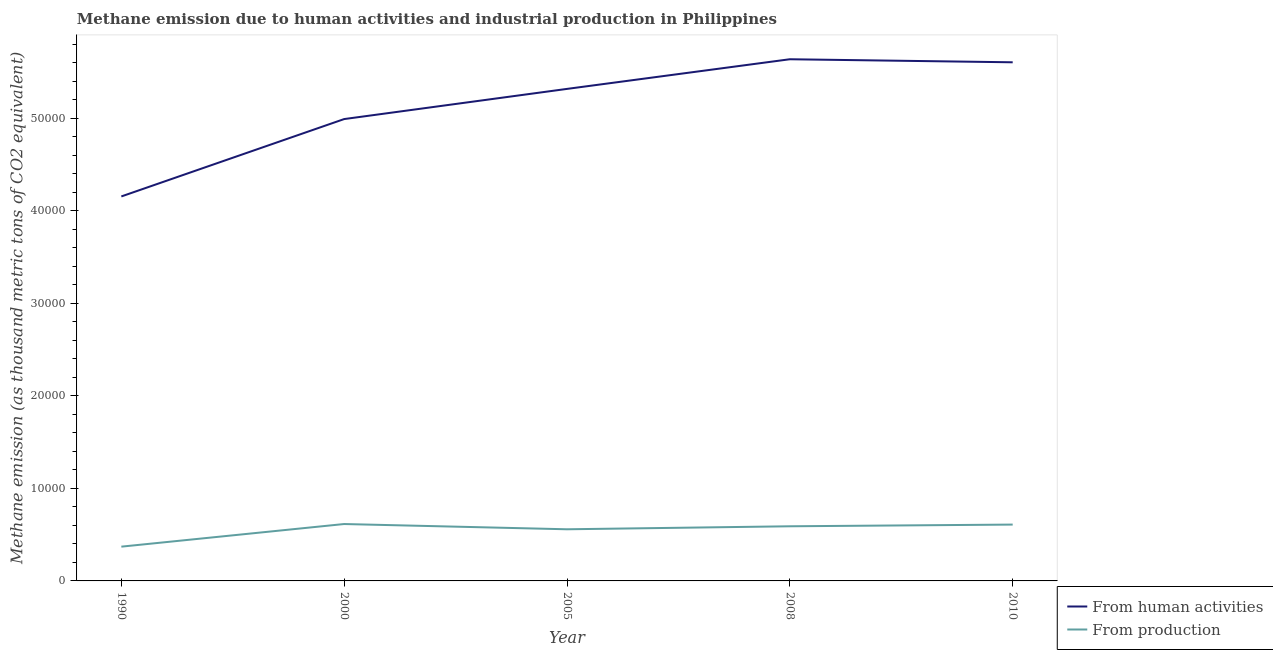Does the line corresponding to amount of emissions generated from industries intersect with the line corresponding to amount of emissions from human activities?
Make the answer very short. No. What is the amount of emissions from human activities in 2005?
Provide a short and direct response. 5.32e+04. Across all years, what is the maximum amount of emissions generated from industries?
Your answer should be very brief. 6149.1. Across all years, what is the minimum amount of emissions from human activities?
Give a very brief answer. 4.16e+04. In which year was the amount of emissions generated from industries minimum?
Keep it short and to the point. 1990. What is the total amount of emissions from human activities in the graph?
Your answer should be very brief. 2.57e+05. What is the difference between the amount of emissions generated from industries in 2005 and that in 2010?
Your answer should be compact. -507.9. What is the difference between the amount of emissions generated from industries in 2010 and the amount of emissions from human activities in 2005?
Ensure brevity in your answer.  -4.71e+04. What is the average amount of emissions from human activities per year?
Offer a terse response. 5.14e+04. In the year 2010, what is the difference between the amount of emissions generated from industries and amount of emissions from human activities?
Your answer should be very brief. -5.00e+04. In how many years, is the amount of emissions from human activities greater than 42000 thousand metric tons?
Make the answer very short. 4. What is the ratio of the amount of emissions generated from industries in 2000 to that in 2005?
Make the answer very short. 1.1. What is the difference between the highest and the second highest amount of emissions from human activities?
Offer a very short reply. 330.4. What is the difference between the highest and the lowest amount of emissions generated from industries?
Your answer should be very brief. 2444.9. In how many years, is the amount of emissions generated from industries greater than the average amount of emissions generated from industries taken over all years?
Your response must be concise. 4. Is the sum of the amount of emissions from human activities in 2005 and 2008 greater than the maximum amount of emissions generated from industries across all years?
Provide a short and direct response. Yes. Is the amount of emissions from human activities strictly greater than the amount of emissions generated from industries over the years?
Offer a very short reply. Yes. What is the difference between two consecutive major ticks on the Y-axis?
Ensure brevity in your answer.  10000. Where does the legend appear in the graph?
Provide a short and direct response. Bottom right. What is the title of the graph?
Provide a short and direct response. Methane emission due to human activities and industrial production in Philippines. Does "Methane" appear as one of the legend labels in the graph?
Make the answer very short. No. What is the label or title of the Y-axis?
Your answer should be compact. Methane emission (as thousand metric tons of CO2 equivalent). What is the Methane emission (as thousand metric tons of CO2 equivalent) in From human activities in 1990?
Offer a very short reply. 4.16e+04. What is the Methane emission (as thousand metric tons of CO2 equivalent) of From production in 1990?
Your response must be concise. 3704.2. What is the Methane emission (as thousand metric tons of CO2 equivalent) of From human activities in 2000?
Your answer should be compact. 4.99e+04. What is the Methane emission (as thousand metric tons of CO2 equivalent) of From production in 2000?
Make the answer very short. 6149.1. What is the Methane emission (as thousand metric tons of CO2 equivalent) in From human activities in 2005?
Keep it short and to the point. 5.32e+04. What is the Methane emission (as thousand metric tons of CO2 equivalent) of From production in 2005?
Ensure brevity in your answer.  5580.9. What is the Methane emission (as thousand metric tons of CO2 equivalent) of From human activities in 2008?
Offer a very short reply. 5.64e+04. What is the Methane emission (as thousand metric tons of CO2 equivalent) in From production in 2008?
Ensure brevity in your answer.  5905.9. What is the Methane emission (as thousand metric tons of CO2 equivalent) of From human activities in 2010?
Offer a very short reply. 5.60e+04. What is the Methane emission (as thousand metric tons of CO2 equivalent) of From production in 2010?
Offer a terse response. 6088.8. Across all years, what is the maximum Methane emission (as thousand metric tons of CO2 equivalent) in From human activities?
Keep it short and to the point. 5.64e+04. Across all years, what is the maximum Methane emission (as thousand metric tons of CO2 equivalent) of From production?
Keep it short and to the point. 6149.1. Across all years, what is the minimum Methane emission (as thousand metric tons of CO2 equivalent) in From human activities?
Make the answer very short. 4.16e+04. Across all years, what is the minimum Methane emission (as thousand metric tons of CO2 equivalent) in From production?
Provide a short and direct response. 3704.2. What is the total Methane emission (as thousand metric tons of CO2 equivalent) of From human activities in the graph?
Provide a succinct answer. 2.57e+05. What is the total Methane emission (as thousand metric tons of CO2 equivalent) of From production in the graph?
Provide a short and direct response. 2.74e+04. What is the difference between the Methane emission (as thousand metric tons of CO2 equivalent) of From human activities in 1990 and that in 2000?
Provide a short and direct response. -8363.6. What is the difference between the Methane emission (as thousand metric tons of CO2 equivalent) in From production in 1990 and that in 2000?
Your answer should be compact. -2444.9. What is the difference between the Methane emission (as thousand metric tons of CO2 equivalent) of From human activities in 1990 and that in 2005?
Your answer should be very brief. -1.16e+04. What is the difference between the Methane emission (as thousand metric tons of CO2 equivalent) in From production in 1990 and that in 2005?
Offer a terse response. -1876.7. What is the difference between the Methane emission (as thousand metric tons of CO2 equivalent) in From human activities in 1990 and that in 2008?
Ensure brevity in your answer.  -1.48e+04. What is the difference between the Methane emission (as thousand metric tons of CO2 equivalent) in From production in 1990 and that in 2008?
Your response must be concise. -2201.7. What is the difference between the Methane emission (as thousand metric tons of CO2 equivalent) of From human activities in 1990 and that in 2010?
Your answer should be compact. -1.45e+04. What is the difference between the Methane emission (as thousand metric tons of CO2 equivalent) in From production in 1990 and that in 2010?
Offer a very short reply. -2384.6. What is the difference between the Methane emission (as thousand metric tons of CO2 equivalent) in From human activities in 2000 and that in 2005?
Make the answer very short. -3260.6. What is the difference between the Methane emission (as thousand metric tons of CO2 equivalent) in From production in 2000 and that in 2005?
Your answer should be compact. 568.2. What is the difference between the Methane emission (as thousand metric tons of CO2 equivalent) in From human activities in 2000 and that in 2008?
Your response must be concise. -6464.7. What is the difference between the Methane emission (as thousand metric tons of CO2 equivalent) in From production in 2000 and that in 2008?
Your answer should be very brief. 243.2. What is the difference between the Methane emission (as thousand metric tons of CO2 equivalent) of From human activities in 2000 and that in 2010?
Make the answer very short. -6134.3. What is the difference between the Methane emission (as thousand metric tons of CO2 equivalent) of From production in 2000 and that in 2010?
Provide a short and direct response. 60.3. What is the difference between the Methane emission (as thousand metric tons of CO2 equivalent) of From human activities in 2005 and that in 2008?
Provide a short and direct response. -3204.1. What is the difference between the Methane emission (as thousand metric tons of CO2 equivalent) in From production in 2005 and that in 2008?
Offer a very short reply. -325. What is the difference between the Methane emission (as thousand metric tons of CO2 equivalent) in From human activities in 2005 and that in 2010?
Ensure brevity in your answer.  -2873.7. What is the difference between the Methane emission (as thousand metric tons of CO2 equivalent) of From production in 2005 and that in 2010?
Provide a short and direct response. -507.9. What is the difference between the Methane emission (as thousand metric tons of CO2 equivalent) of From human activities in 2008 and that in 2010?
Ensure brevity in your answer.  330.4. What is the difference between the Methane emission (as thousand metric tons of CO2 equivalent) in From production in 2008 and that in 2010?
Offer a terse response. -182.9. What is the difference between the Methane emission (as thousand metric tons of CO2 equivalent) of From human activities in 1990 and the Methane emission (as thousand metric tons of CO2 equivalent) of From production in 2000?
Offer a terse response. 3.54e+04. What is the difference between the Methane emission (as thousand metric tons of CO2 equivalent) of From human activities in 1990 and the Methane emission (as thousand metric tons of CO2 equivalent) of From production in 2005?
Offer a very short reply. 3.60e+04. What is the difference between the Methane emission (as thousand metric tons of CO2 equivalent) in From human activities in 1990 and the Methane emission (as thousand metric tons of CO2 equivalent) in From production in 2008?
Your response must be concise. 3.56e+04. What is the difference between the Methane emission (as thousand metric tons of CO2 equivalent) of From human activities in 1990 and the Methane emission (as thousand metric tons of CO2 equivalent) of From production in 2010?
Make the answer very short. 3.55e+04. What is the difference between the Methane emission (as thousand metric tons of CO2 equivalent) in From human activities in 2000 and the Methane emission (as thousand metric tons of CO2 equivalent) in From production in 2005?
Provide a short and direct response. 4.43e+04. What is the difference between the Methane emission (as thousand metric tons of CO2 equivalent) of From human activities in 2000 and the Methane emission (as thousand metric tons of CO2 equivalent) of From production in 2008?
Give a very brief answer. 4.40e+04. What is the difference between the Methane emission (as thousand metric tons of CO2 equivalent) of From human activities in 2000 and the Methane emission (as thousand metric tons of CO2 equivalent) of From production in 2010?
Your answer should be very brief. 4.38e+04. What is the difference between the Methane emission (as thousand metric tons of CO2 equivalent) in From human activities in 2005 and the Methane emission (as thousand metric tons of CO2 equivalent) in From production in 2008?
Offer a terse response. 4.73e+04. What is the difference between the Methane emission (as thousand metric tons of CO2 equivalent) of From human activities in 2005 and the Methane emission (as thousand metric tons of CO2 equivalent) of From production in 2010?
Keep it short and to the point. 4.71e+04. What is the difference between the Methane emission (as thousand metric tons of CO2 equivalent) in From human activities in 2008 and the Methane emission (as thousand metric tons of CO2 equivalent) in From production in 2010?
Offer a very short reply. 5.03e+04. What is the average Methane emission (as thousand metric tons of CO2 equivalent) of From human activities per year?
Keep it short and to the point. 5.14e+04. What is the average Methane emission (as thousand metric tons of CO2 equivalent) in From production per year?
Your answer should be very brief. 5485.78. In the year 1990, what is the difference between the Methane emission (as thousand metric tons of CO2 equivalent) of From human activities and Methane emission (as thousand metric tons of CO2 equivalent) of From production?
Your answer should be very brief. 3.78e+04. In the year 2000, what is the difference between the Methane emission (as thousand metric tons of CO2 equivalent) of From human activities and Methane emission (as thousand metric tons of CO2 equivalent) of From production?
Keep it short and to the point. 4.38e+04. In the year 2005, what is the difference between the Methane emission (as thousand metric tons of CO2 equivalent) in From human activities and Methane emission (as thousand metric tons of CO2 equivalent) in From production?
Your answer should be very brief. 4.76e+04. In the year 2008, what is the difference between the Methane emission (as thousand metric tons of CO2 equivalent) of From human activities and Methane emission (as thousand metric tons of CO2 equivalent) of From production?
Ensure brevity in your answer.  5.05e+04. In the year 2010, what is the difference between the Methane emission (as thousand metric tons of CO2 equivalent) of From human activities and Methane emission (as thousand metric tons of CO2 equivalent) of From production?
Your answer should be compact. 5.00e+04. What is the ratio of the Methane emission (as thousand metric tons of CO2 equivalent) in From human activities in 1990 to that in 2000?
Keep it short and to the point. 0.83. What is the ratio of the Methane emission (as thousand metric tons of CO2 equivalent) in From production in 1990 to that in 2000?
Make the answer very short. 0.6. What is the ratio of the Methane emission (as thousand metric tons of CO2 equivalent) of From human activities in 1990 to that in 2005?
Ensure brevity in your answer.  0.78. What is the ratio of the Methane emission (as thousand metric tons of CO2 equivalent) of From production in 1990 to that in 2005?
Your answer should be very brief. 0.66. What is the ratio of the Methane emission (as thousand metric tons of CO2 equivalent) in From human activities in 1990 to that in 2008?
Your answer should be compact. 0.74. What is the ratio of the Methane emission (as thousand metric tons of CO2 equivalent) of From production in 1990 to that in 2008?
Provide a succinct answer. 0.63. What is the ratio of the Methane emission (as thousand metric tons of CO2 equivalent) in From human activities in 1990 to that in 2010?
Offer a terse response. 0.74. What is the ratio of the Methane emission (as thousand metric tons of CO2 equivalent) of From production in 1990 to that in 2010?
Your answer should be compact. 0.61. What is the ratio of the Methane emission (as thousand metric tons of CO2 equivalent) of From human activities in 2000 to that in 2005?
Your response must be concise. 0.94. What is the ratio of the Methane emission (as thousand metric tons of CO2 equivalent) in From production in 2000 to that in 2005?
Provide a succinct answer. 1.1. What is the ratio of the Methane emission (as thousand metric tons of CO2 equivalent) of From human activities in 2000 to that in 2008?
Give a very brief answer. 0.89. What is the ratio of the Methane emission (as thousand metric tons of CO2 equivalent) of From production in 2000 to that in 2008?
Your answer should be very brief. 1.04. What is the ratio of the Methane emission (as thousand metric tons of CO2 equivalent) of From human activities in 2000 to that in 2010?
Make the answer very short. 0.89. What is the ratio of the Methane emission (as thousand metric tons of CO2 equivalent) in From production in 2000 to that in 2010?
Offer a terse response. 1.01. What is the ratio of the Methane emission (as thousand metric tons of CO2 equivalent) in From human activities in 2005 to that in 2008?
Your answer should be very brief. 0.94. What is the ratio of the Methane emission (as thousand metric tons of CO2 equivalent) of From production in 2005 to that in 2008?
Offer a terse response. 0.94. What is the ratio of the Methane emission (as thousand metric tons of CO2 equivalent) of From human activities in 2005 to that in 2010?
Your answer should be compact. 0.95. What is the ratio of the Methane emission (as thousand metric tons of CO2 equivalent) of From production in 2005 to that in 2010?
Make the answer very short. 0.92. What is the ratio of the Methane emission (as thousand metric tons of CO2 equivalent) in From human activities in 2008 to that in 2010?
Keep it short and to the point. 1.01. What is the difference between the highest and the second highest Methane emission (as thousand metric tons of CO2 equivalent) of From human activities?
Provide a succinct answer. 330.4. What is the difference between the highest and the second highest Methane emission (as thousand metric tons of CO2 equivalent) in From production?
Provide a short and direct response. 60.3. What is the difference between the highest and the lowest Methane emission (as thousand metric tons of CO2 equivalent) in From human activities?
Offer a terse response. 1.48e+04. What is the difference between the highest and the lowest Methane emission (as thousand metric tons of CO2 equivalent) of From production?
Give a very brief answer. 2444.9. 